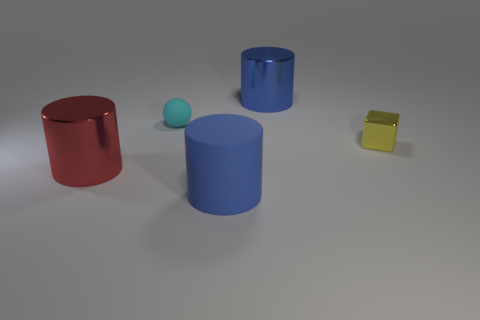How would you describe the arrangement of the objects in terms of their colors and shapes? The arrangement of the objects presents a visually appealing diversity in colors and shapes. Starting from the left, we have a red cylinder, a tiny cyan sphere, a blue cylinder directly behind the sphere, and finally a small yellow cube to the far right. The objects are positioned with a moderate distance between them, placed against a neutral background which accentuates their colors. 